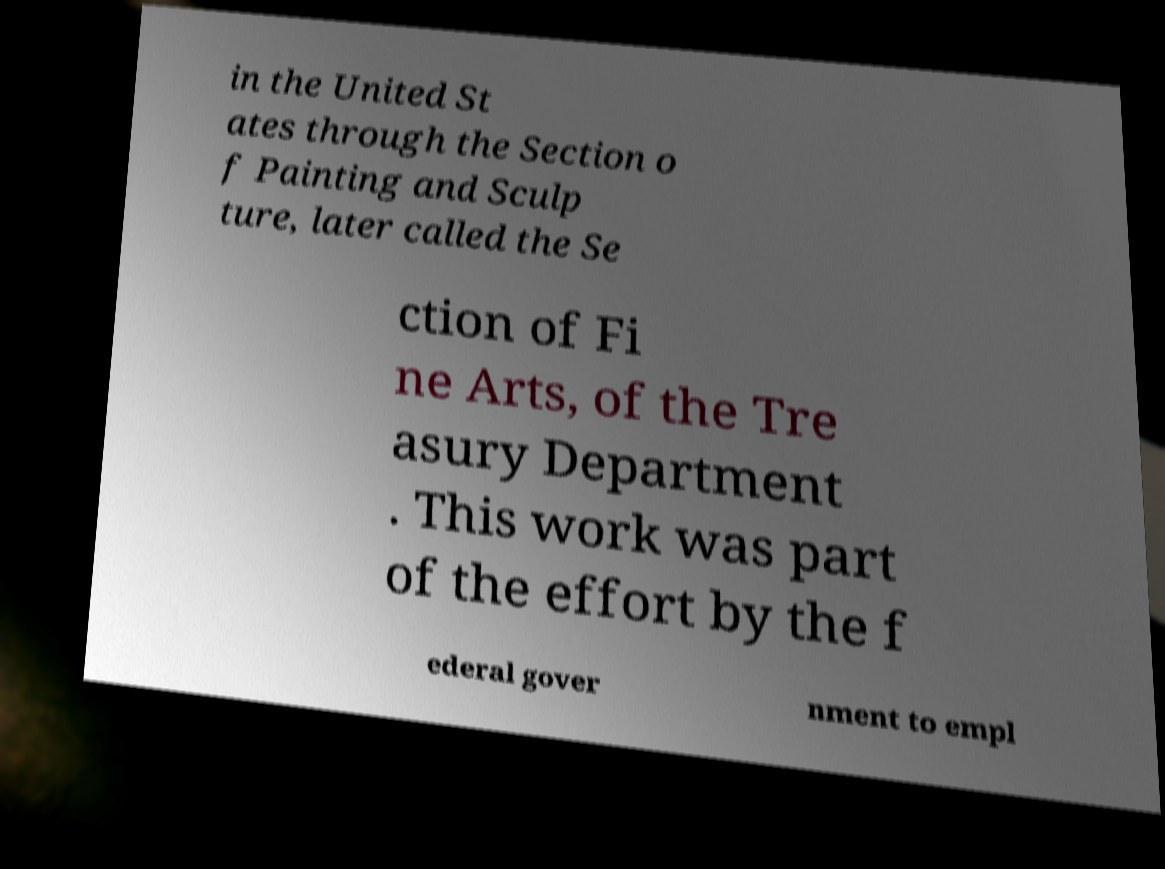Can you read and provide the text displayed in the image?This photo seems to have some interesting text. Can you extract and type it out for me? in the United St ates through the Section o f Painting and Sculp ture, later called the Se ction of Fi ne Arts, of the Tre asury Department . This work was part of the effort by the f ederal gover nment to empl 